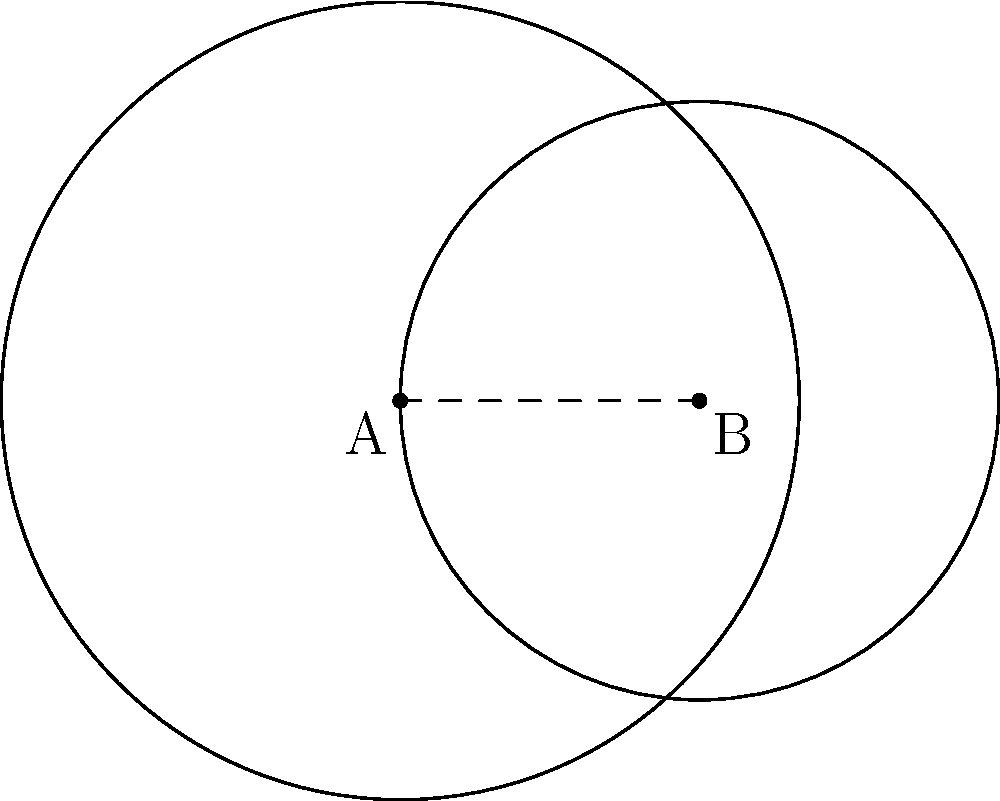You're planning a romantic evening and have circled two potential date spots on your city map. Spot A has a radius of 4 km, and Spot B has a radius of 3 km. The centers of these spots are 3 km apart. What is the area of the overlapping region where you might bump into your crush while trying to decide between the two locations? To find the area of the overlapping region, we need to use the formula for the area of intersection of two circles. Let's approach this step-by-step:

1) First, we need to calculate the distance $d$ between the centers of the circles. We're given that $d = 3$ km.

2) Now, we'll use the formula for the area of intersection:

   $A = r_1^2 \arccos(\frac{d^2 + r_1^2 - r_2^2}{2dr_1}) + r_2^2 \arccos(\frac{d^2 + r_2^2 - r_1^2}{2dr_2}) - \frac{1}{2}\sqrt{(-d+r_1+r_2)(d+r_1-r_2)(d-r_1+r_2)(d+r_1+r_2)}$

   Where $r_1 = 4$ km and $r_2 = 3$ km.

3) Let's substitute these values:

   $A = 4^2 \arccos(\frac{3^2 + 4^2 - 3^2}{2 \cdot 3 \cdot 4}) + 3^2 \arccos(\frac{3^2 + 3^2 - 4^2}{2 \cdot 3 \cdot 3}) - \frac{1}{2}\sqrt{(-3+4+3)(3+4-3)(3-4+3)(3+4+3)}$

4) Simplify:

   $A = 16 \arccos(\frac{25}{24}) + 9 \arccos(\frac{10}{18}) - \frac{1}{2}\sqrt{4 \cdot 4 \cdot 2 \cdot 10}$

5) Calculate:

   $A \approx 16 \cdot 0.2731 + 9 \cdot 1.0472 - \frac{1}{2}\sqrt{320}$
   $A \approx 4.3696 + 9.4248 - 8.9443$
   $A \approx 4.8501$ km²

Therefore, the area of the overlapping region is approximately 4.8501 km².
Answer: $4.8501$ km² 